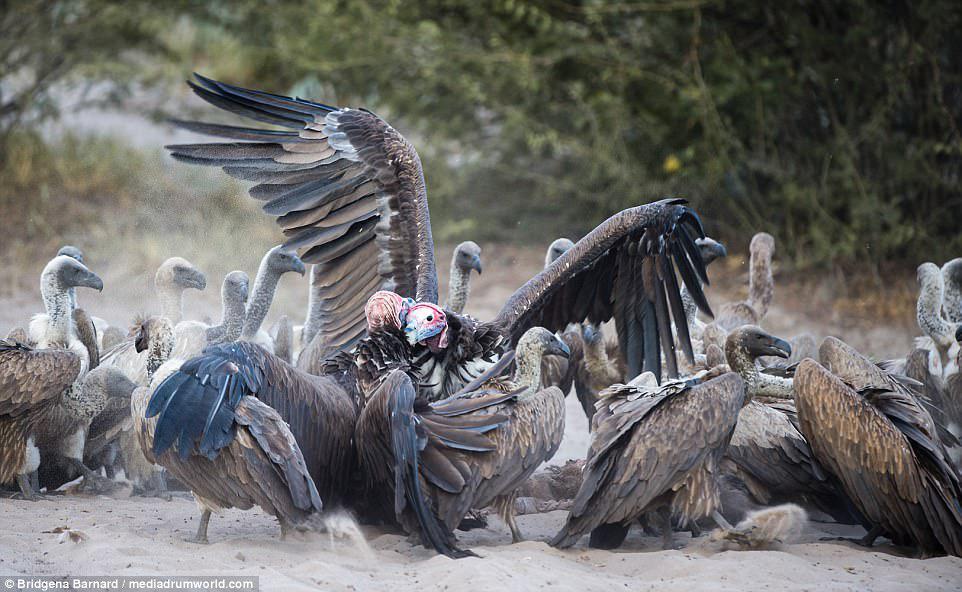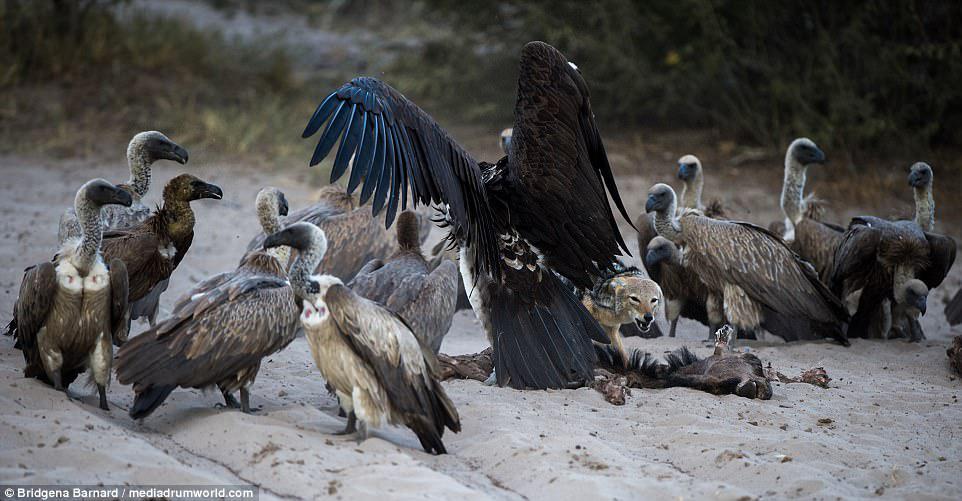The first image is the image on the left, the second image is the image on the right. Assess this claim about the two images: "There is a group of at least 5 vultures in the right image.". Correct or not? Answer yes or no. Yes. The first image is the image on the left, the second image is the image on the right. Examine the images to the left and right. Is the description "Three or more vultures perched on a branch are visible." accurate? Answer yes or no. No. 